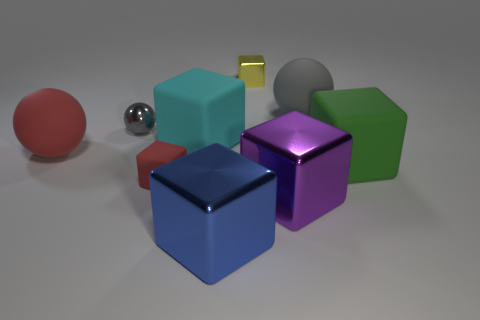The cube that is both behind the big green rubber thing and in front of the gray rubber sphere is what color?
Offer a terse response. Cyan. Are there any tiny red rubber things that have the same shape as the blue object?
Ensure brevity in your answer.  Yes. What material is the large blue block?
Your response must be concise. Metal. Are there any cyan matte things right of the large cyan matte block?
Provide a short and direct response. No. Do the green rubber object and the blue metallic object have the same shape?
Your answer should be compact. Yes. How many other things are the same size as the cyan object?
Give a very brief answer. 5. How many objects are spheres that are on the left side of the small red thing or cyan matte things?
Offer a very short reply. 3. The tiny ball is what color?
Provide a succinct answer. Gray. There is a tiny cube that is to the left of the blue object; what material is it?
Your answer should be very brief. Rubber. There is a purple metal object; does it have the same shape as the gray object to the right of the purple shiny cube?
Make the answer very short. No. 